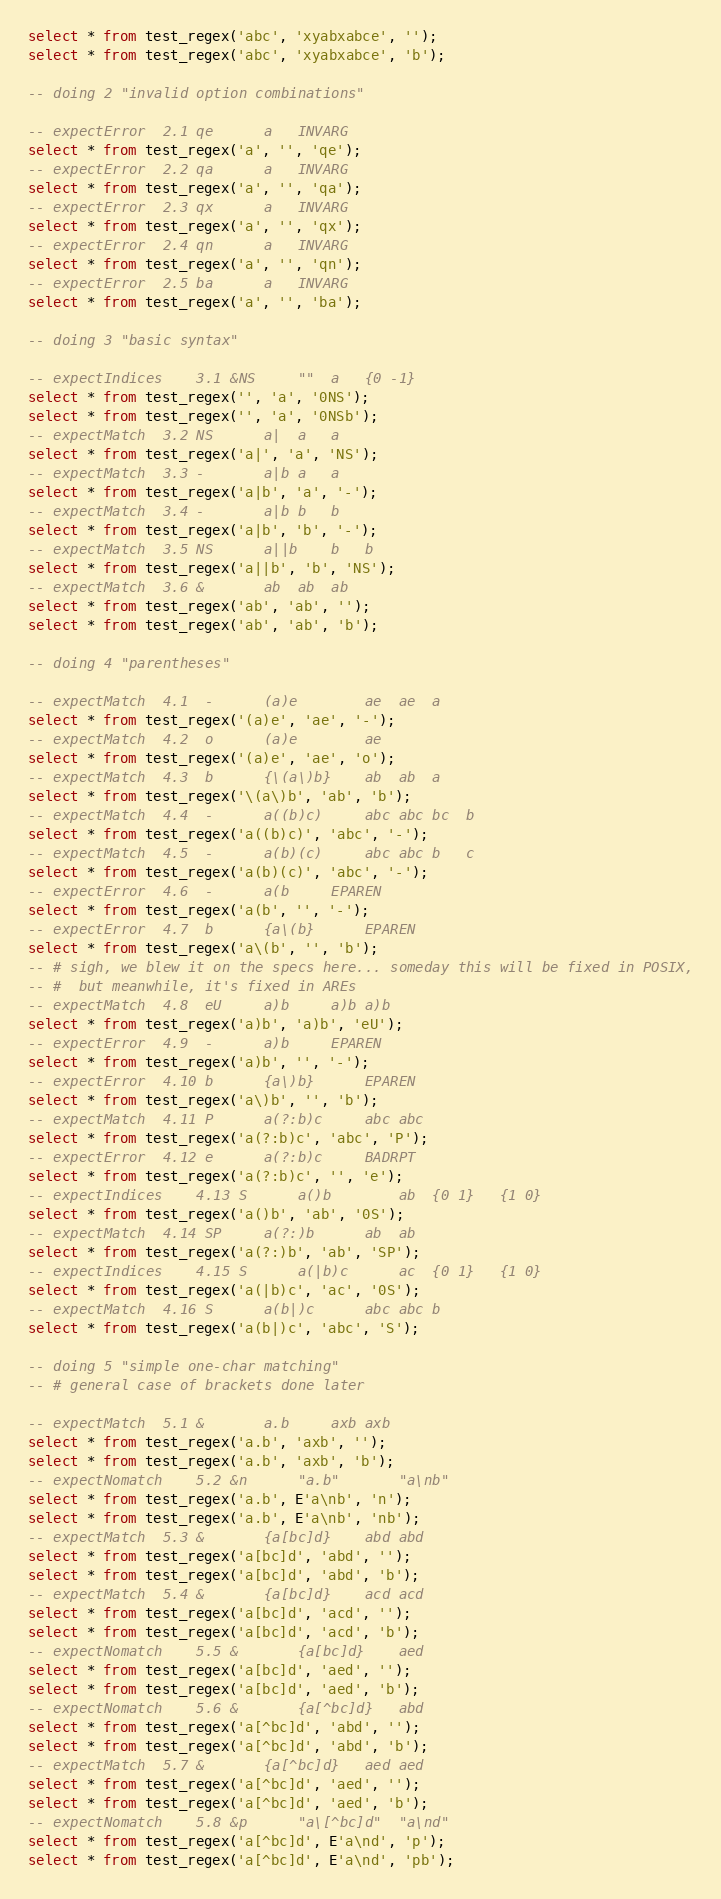Convert code to text. <code><loc_0><loc_0><loc_500><loc_500><_SQL_>select * from test_regex('abc', 'xyabxabce', '');
select * from test_regex('abc', 'xyabxabce', 'b');

-- doing 2 "invalid option combinations"

-- expectError	2.1 qe		a	INVARG
select * from test_regex('a', '', 'qe');
-- expectError	2.2 qa		a	INVARG
select * from test_regex('a', '', 'qa');
-- expectError	2.3 qx		a	INVARG
select * from test_regex('a', '', 'qx');
-- expectError	2.4 qn		a	INVARG
select * from test_regex('a', '', 'qn');
-- expectError	2.5 ba		a	INVARG
select * from test_regex('a', '', 'ba');

-- doing 3 "basic syntax"

-- expectIndices	3.1 &NS		""	a	{0 -1}
select * from test_regex('', 'a', '0NS');
select * from test_regex('', 'a', '0NSb');
-- expectMatch	3.2 NS		a|	a	a
select * from test_regex('a|', 'a', 'NS');
-- expectMatch	3.3 -		a|b	a	a
select * from test_regex('a|b', 'a', '-');
-- expectMatch	3.4 -		a|b	b	b
select * from test_regex('a|b', 'b', '-');
-- expectMatch	3.5 NS		a||b	b	b
select * from test_regex('a||b', 'b', 'NS');
-- expectMatch	3.6 &		ab	ab	ab
select * from test_regex('ab', 'ab', '');
select * from test_regex('ab', 'ab', 'b');

-- doing 4 "parentheses"

-- expectMatch	4.1  -		(a)e		ae	ae	a
select * from test_regex('(a)e', 'ae', '-');
-- expectMatch	4.2  o		(a)e		ae
select * from test_regex('(a)e', 'ae', 'o');
-- expectMatch	4.3  b		{\(a\)b}	ab	ab	a
select * from test_regex('\(a\)b', 'ab', 'b');
-- expectMatch	4.4  -		a((b)c)		abc	abc	bc	b
select * from test_regex('a((b)c)', 'abc', '-');
-- expectMatch	4.5  -		a(b)(c)		abc	abc	b	c
select * from test_regex('a(b)(c)', 'abc', '-');
-- expectError	4.6  -		a(b		EPAREN
select * from test_regex('a(b', '', '-');
-- expectError	4.7  b		{a\(b}		EPAREN
select * from test_regex('a\(b', '', 'b');
-- # sigh, we blew it on the specs here... someday this will be fixed in POSIX,
-- #  but meanwhile, it's fixed in AREs
-- expectMatch	4.8  eU		a)b		a)b	a)b
select * from test_regex('a)b', 'a)b', 'eU');
-- expectError	4.9  -		a)b		EPAREN
select * from test_regex('a)b', '', '-');
-- expectError	4.10 b		{a\)b}		EPAREN
select * from test_regex('a\)b', '', 'b');
-- expectMatch	4.11 P		a(?:b)c		abc	abc
select * from test_regex('a(?:b)c', 'abc', 'P');
-- expectError	4.12 e		a(?:b)c		BADRPT
select * from test_regex('a(?:b)c', '', 'e');
-- expectIndices	4.13 S		a()b		ab	{0 1}	{1 0}
select * from test_regex('a()b', 'ab', '0S');
-- expectMatch	4.14 SP		a(?:)b		ab	ab
select * from test_regex('a(?:)b', 'ab', 'SP');
-- expectIndices	4.15 S		a(|b)c		ac	{0 1}	{1 0}
select * from test_regex('a(|b)c', 'ac', '0S');
-- expectMatch	4.16 S		a(b|)c		abc	abc	b
select * from test_regex('a(b|)c', 'abc', 'S');

-- doing 5 "simple one-char matching"
-- # general case of brackets done later

-- expectMatch	5.1 &		a.b		axb	axb
select * from test_regex('a.b', 'axb', '');
select * from test_regex('a.b', 'axb', 'b');
-- expectNomatch	5.2 &n		"a.b"		"a\nb"
select * from test_regex('a.b', E'a\nb', 'n');
select * from test_regex('a.b', E'a\nb', 'nb');
-- expectMatch	5.3 &		{a[bc]d}	abd	abd
select * from test_regex('a[bc]d', 'abd', '');
select * from test_regex('a[bc]d', 'abd', 'b');
-- expectMatch	5.4 &		{a[bc]d}	acd	acd
select * from test_regex('a[bc]d', 'acd', '');
select * from test_regex('a[bc]d', 'acd', 'b');
-- expectNomatch	5.5 &		{a[bc]d}	aed
select * from test_regex('a[bc]d', 'aed', '');
select * from test_regex('a[bc]d', 'aed', 'b');
-- expectNomatch	5.6 &		{a[^bc]d}	abd
select * from test_regex('a[^bc]d', 'abd', '');
select * from test_regex('a[^bc]d', 'abd', 'b');
-- expectMatch	5.7 &		{a[^bc]d}	aed	aed
select * from test_regex('a[^bc]d', 'aed', '');
select * from test_regex('a[^bc]d', 'aed', 'b');
-- expectNomatch	5.8 &p		"a\[^bc]d"	"a\nd"
select * from test_regex('a[^bc]d', E'a\nd', 'p');
select * from test_regex('a[^bc]d', E'a\nd', 'pb');
</code> 